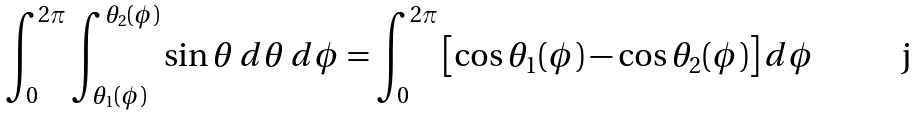<formula> <loc_0><loc_0><loc_500><loc_500>\int _ { 0 } ^ { 2 \pi } \int _ { { \theta _ { 1 } } ( { \phi } ) } ^ { { \theta _ { 2 } } ( { \phi } ) } \sin { \theta } \, d { \theta } \, d { \phi } = \int _ { 0 } ^ { 2 \pi } \left [ \cos { \theta _ { 1 } } ( { \phi } ) - \cos { \theta _ { 2 } } ( { \phi } ) \right ] d { \phi }</formula> 